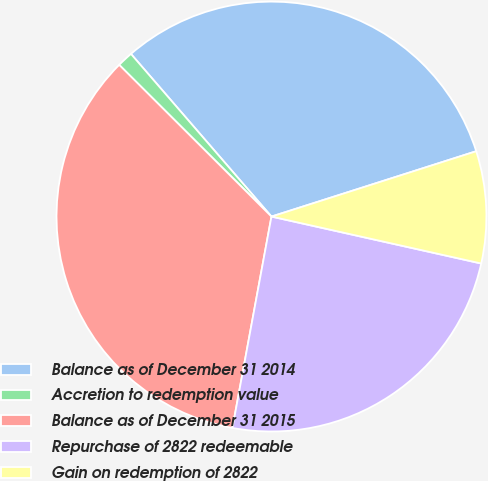Convert chart. <chart><loc_0><loc_0><loc_500><loc_500><pie_chart><fcel>Balance as of December 31 2014<fcel>Accretion to redemption value<fcel>Balance as of December 31 2015<fcel>Repurchase of 2822 redeemable<fcel>Gain on redemption of 2822<nl><fcel>31.42%<fcel>1.19%<fcel>34.56%<fcel>24.4%<fcel>8.42%<nl></chart> 